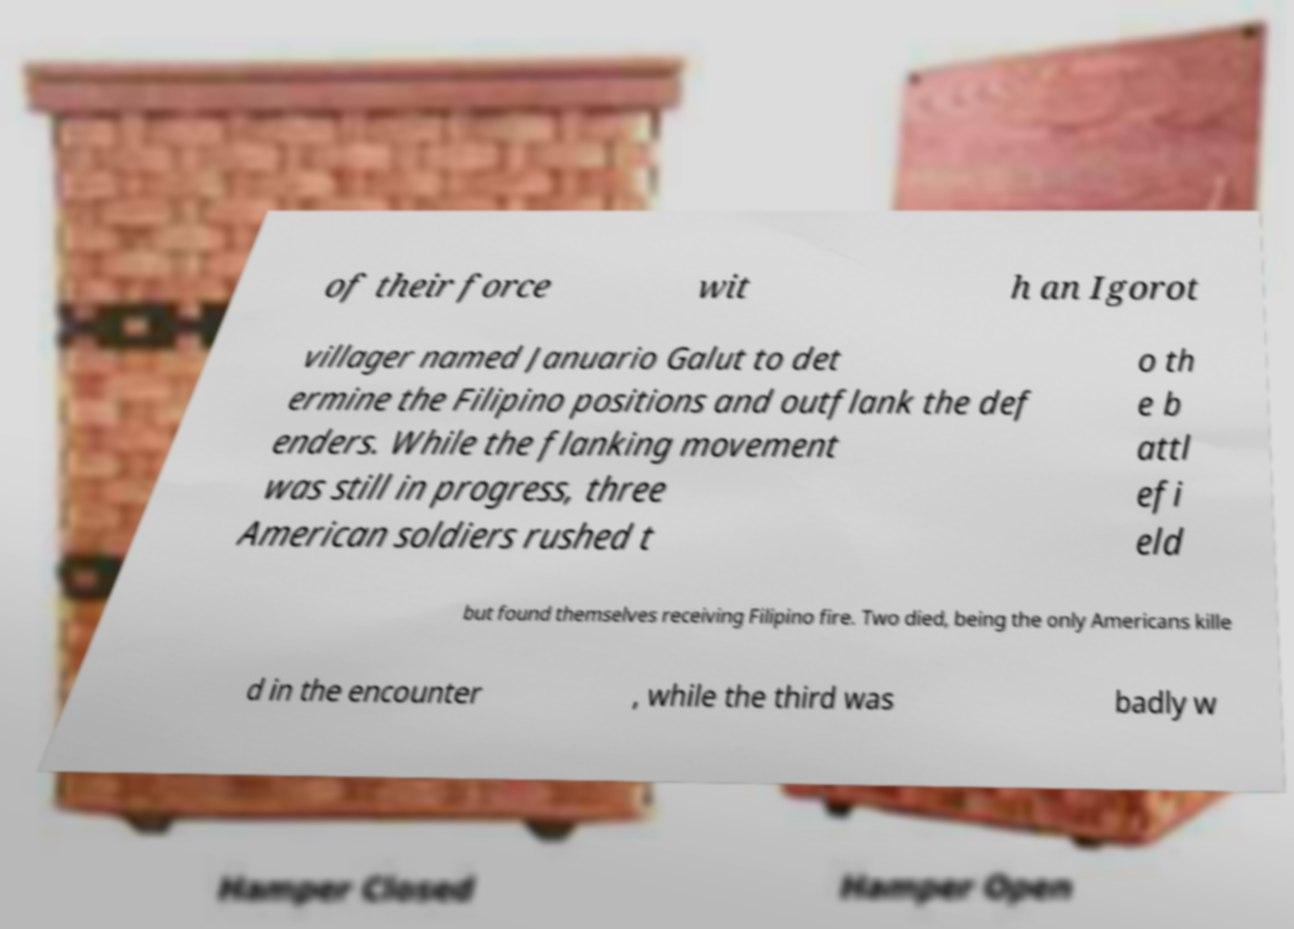Please identify and transcribe the text found in this image. of their force wit h an Igorot villager named Januario Galut to det ermine the Filipino positions and outflank the def enders. While the flanking movement was still in progress, three American soldiers rushed t o th e b attl efi eld but found themselves receiving Filipino fire. Two died, being the only Americans kille d in the encounter , while the third was badly w 